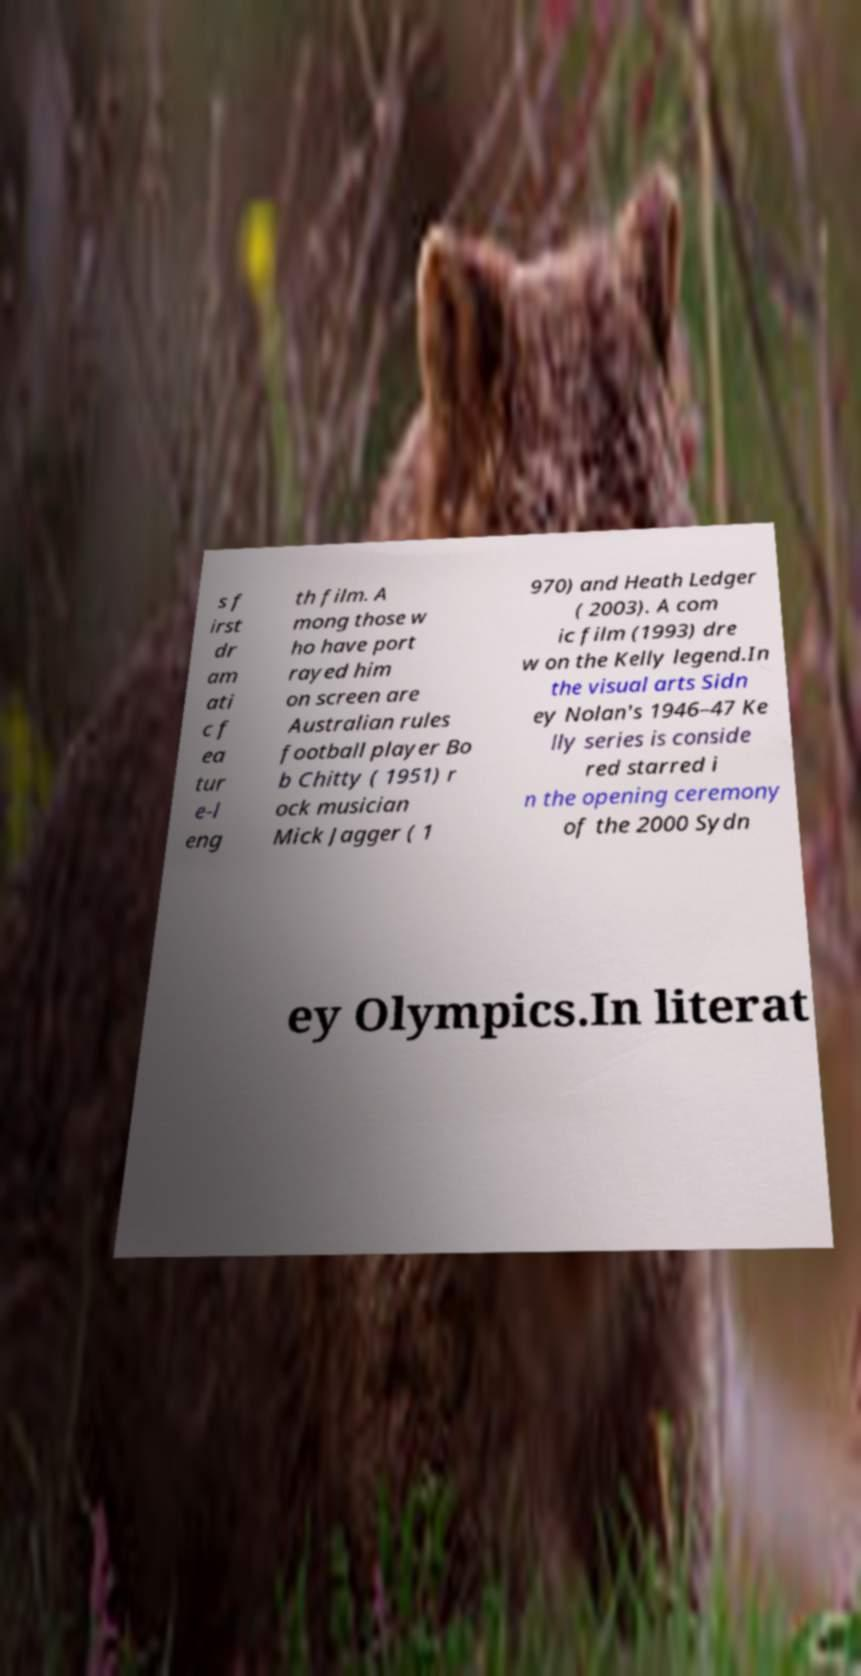Can you read and provide the text displayed in the image?This photo seems to have some interesting text. Can you extract and type it out for me? s f irst dr am ati c f ea tur e-l eng th film. A mong those w ho have port rayed him on screen are Australian rules football player Bo b Chitty ( 1951) r ock musician Mick Jagger ( 1 970) and Heath Ledger ( 2003). A com ic film (1993) dre w on the Kelly legend.In the visual arts Sidn ey Nolan's 1946–47 Ke lly series is conside red starred i n the opening ceremony of the 2000 Sydn ey Olympics.In literat 